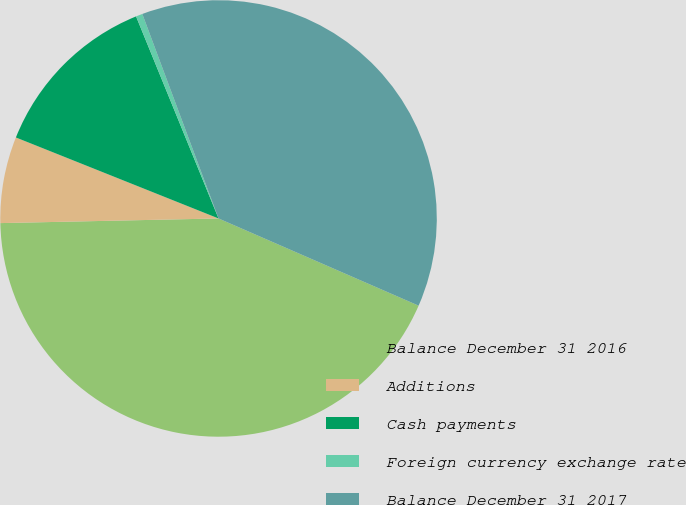<chart> <loc_0><loc_0><loc_500><loc_500><pie_chart><fcel>Balance December 31 2016<fcel>Additions<fcel>Cash payments<fcel>Foreign currency exchange rate<fcel>Balance December 31 2017<nl><fcel>43.12%<fcel>6.39%<fcel>12.78%<fcel>0.49%<fcel>37.22%<nl></chart> 